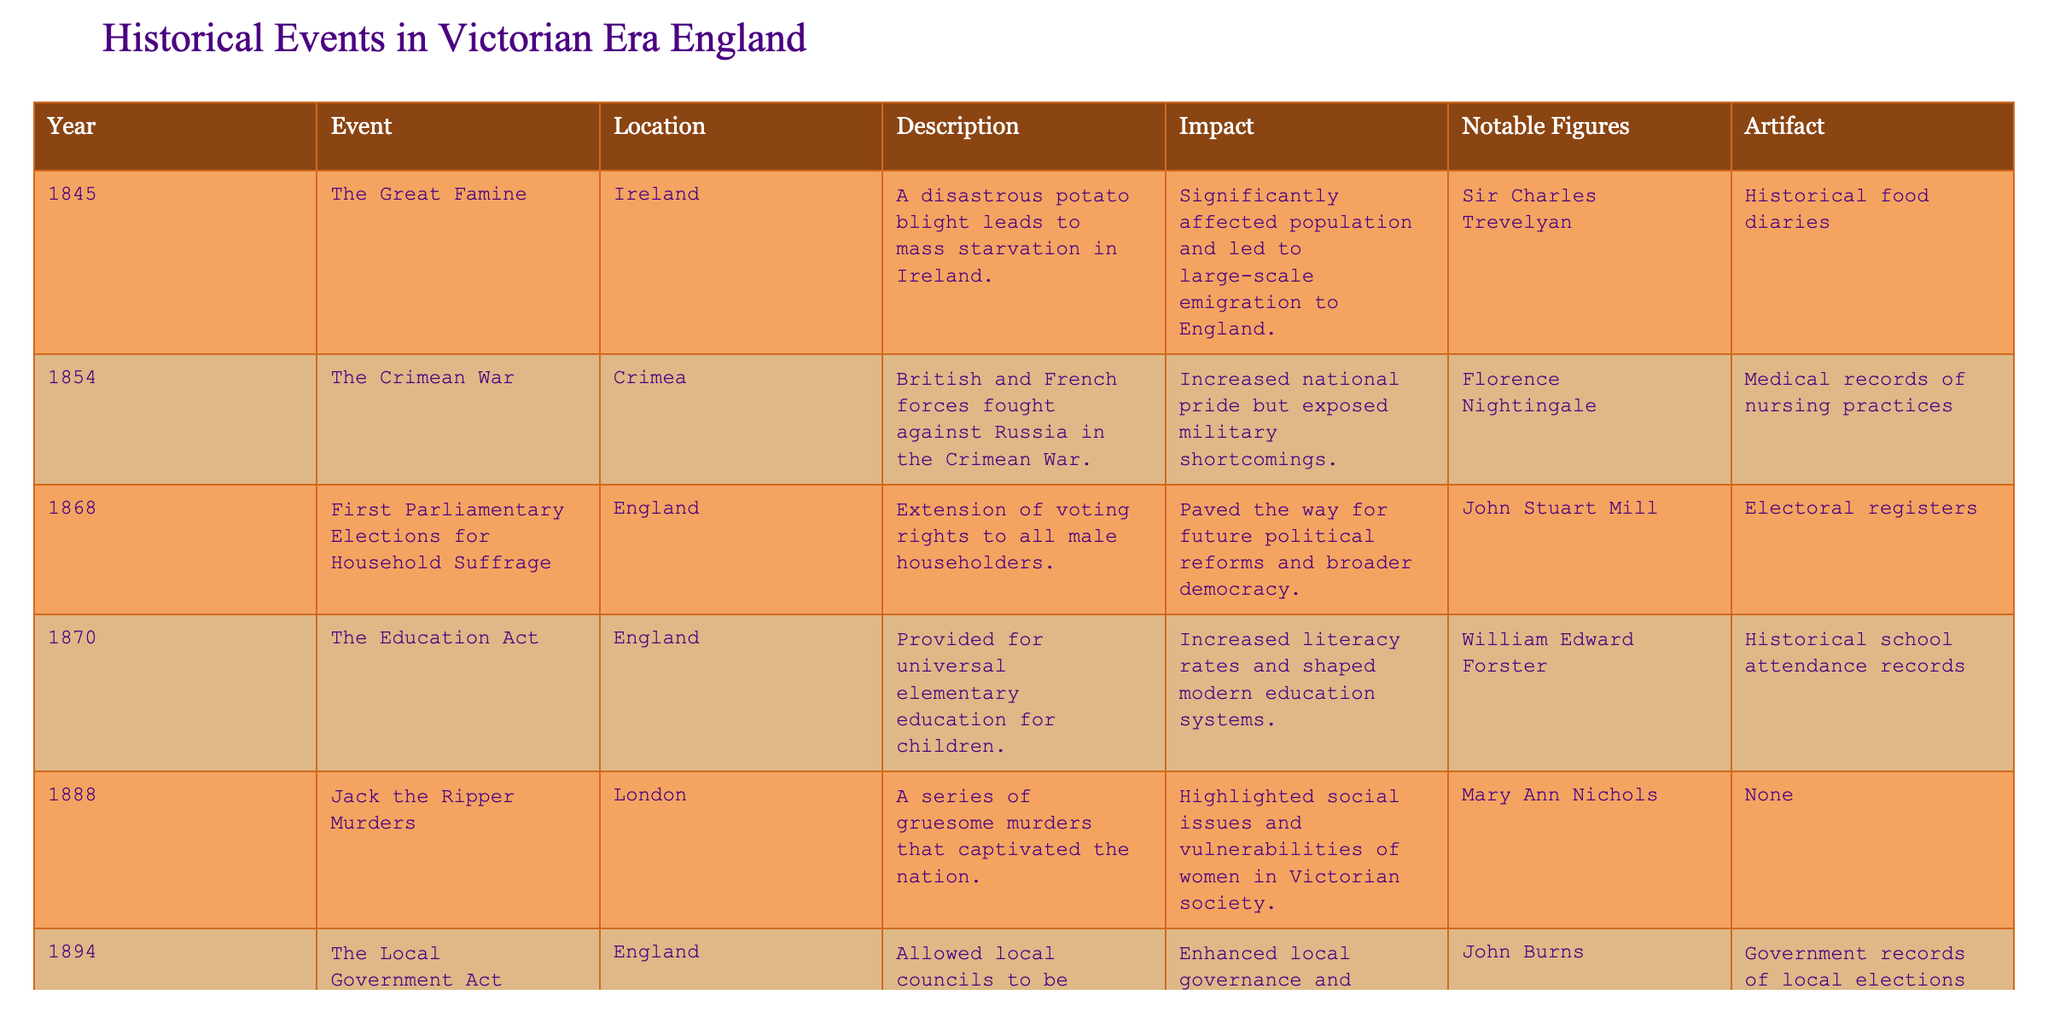What year did the Education Act take place? The table lists the events chronologically by year; the Education Act is listed under the year 1870.
Answer: 1870 Who was a notable figure associated with the Crimean War? The notable figure for the Crimean War listed in the table is Florence Nightingale, who is known for her contributions during that time.
Answer: Florence Nightingale How many events took place in England? By counting the entries, we see that there are five events listed under the location 'England' (The First Parliamentary Elections, The Education Act, The Local Government Act, and the Jack the Ripper Murders).
Answer: 5 Did the Great Famine lead to emigration to England? The description for the Great Famine notes that it led to large-scale emigration to England due to mass starvation.
Answer: Yes What was the main impact of the Jack the Ripper murders? The table describes the impact of the Jack the Ripper murders as highlighting social issues and vulnerabilities of women in Victorian society.
Answer: Highlighted social issues What year had the earliest historical event mentioned in the table? Among the events listed, the earliest event is the Great Famine, which occurred in 1845.
Answer: 1845 How many notable figures are listed in relation to the events? By reviewing the 'Notable Figures' column, there are five distinct individuals mentioned across various events.
Answer: 5 Which event had a significant impact on local governance? The Local Government Act of 1894 is noted to have enhanced local governance and representation, indicating its significant impact.
Answer: The Local Government Act What was the artifact associated with the Education Act? The table lists historical school attendance records as the artifact associated with the Education Act that signifies its importance.
Answer: Historical school attendance records Is there an event that affected women’s social issues in Victorian society? Yes, the Jack the Ripper murders are explicitly mentioned as highlighting social issues and vulnerabilities of women during that time.
Answer: Yes What is the relationship between the Second Boer War and public opinion? The impact of the Second Boer War describes it as straining resources and shaping public opinion regarding imperialism.
Answer: Strained resources and public opinion regarding imperialism Summarize the overall impact of the Great Famine as described in the table. The overall impact of the Great Famine significantly affected the population and led to large-scale emigration, suggesting a massive demographic change.
Answer: Significantly affected population, led to emigration 